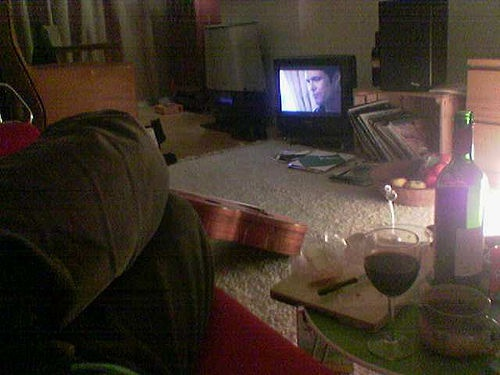Describe the objects in this image and their specific colors. I can see people in black, maroon, and gray tones, tv in black, lavender, navy, and purple tones, bottle in black, gray, darkgray, and lightgray tones, couch in black, maroon, and brown tones, and cup in black and gray tones in this image. 